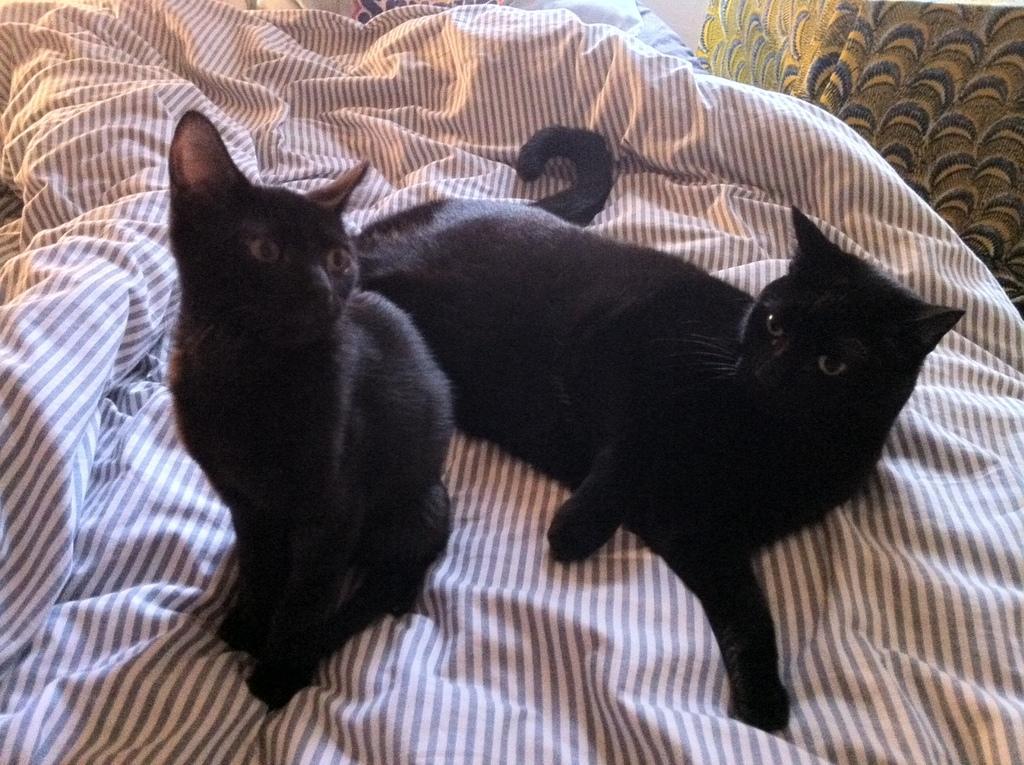Please provide a concise description of this image. In this picture I can see 2 black color cats, which are on a cloth which is of white and brown color and I see another on the top right corner of this image. 